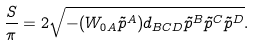Convert formula to latex. <formula><loc_0><loc_0><loc_500><loc_500>\frac { S } { \pi } = 2 \sqrt { - ( W _ { 0 A } \tilde { p } ^ { A } ) d _ { B C D } \tilde { p } ^ { B } \tilde { p } ^ { C } \tilde { p } ^ { D } } .</formula> 